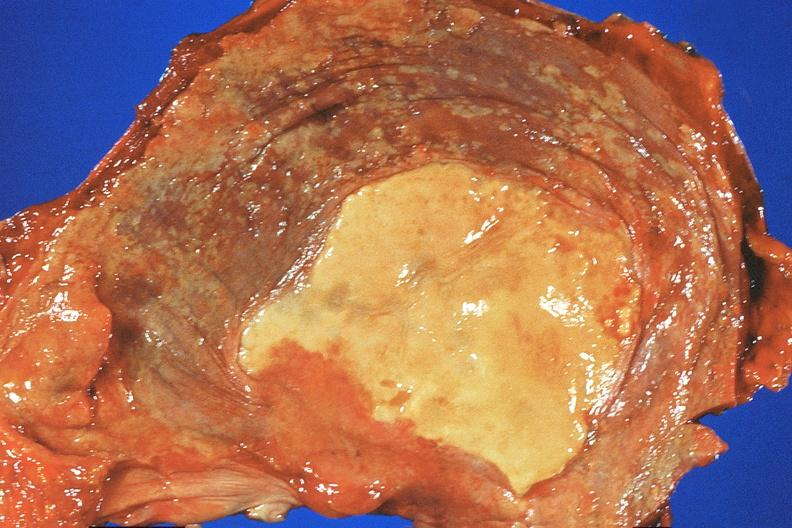what does this image show?
Answer the question using a single word or phrase. Diaphragm 